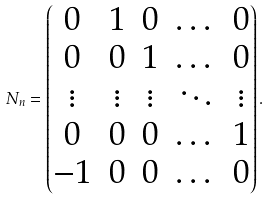Convert formula to latex. <formula><loc_0><loc_0><loc_500><loc_500>N _ { n } = \begin{pmatrix} 0 & 1 & 0 & \dots & 0 \\ 0 & 0 & 1 & \dots & 0 \\ \vdots & \vdots & \vdots & \ddots & \vdots \\ 0 & 0 & 0 & \dots & 1 \\ - 1 & 0 & 0 & \dots & 0 \end{pmatrix} .</formula> 